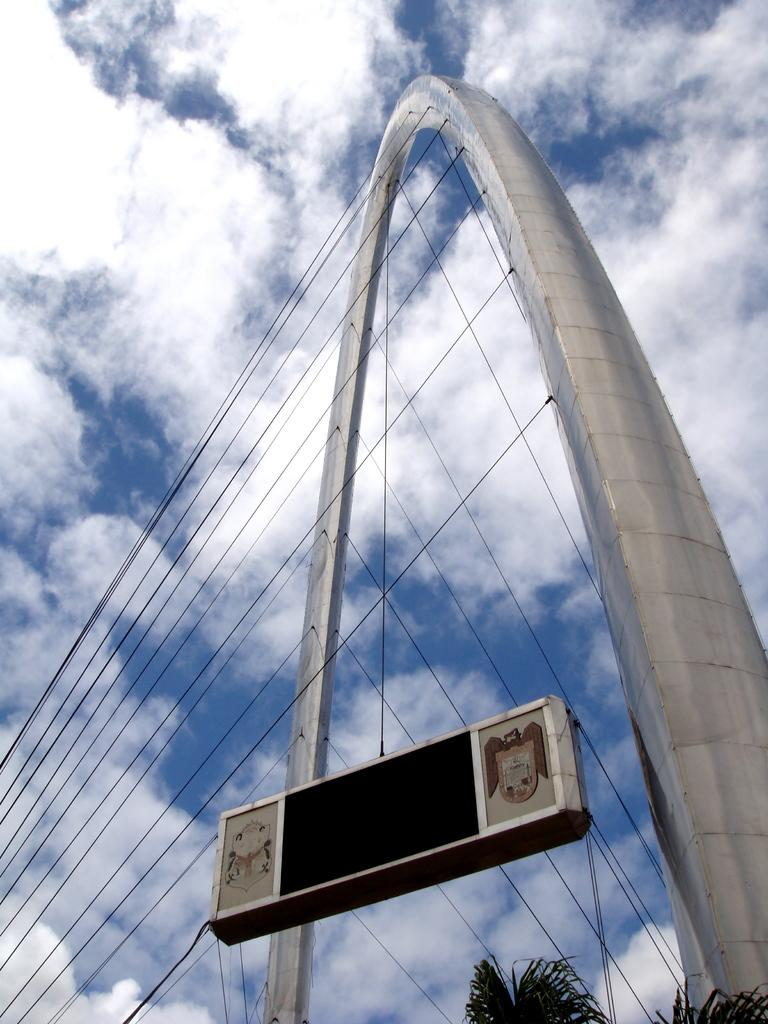What is the main structure in the center of the image? There is an arch in the center of the image. What else can be seen in the center of the image? There are wires, a banner, and a tree in the center of the image. What is visible in the background of the image? The sky is visible in the background of the image, and there are clouds present. What type of trousers are hanging on the tree in the image? There are no trousers present in the image; the tree is not associated with any clothing items. 